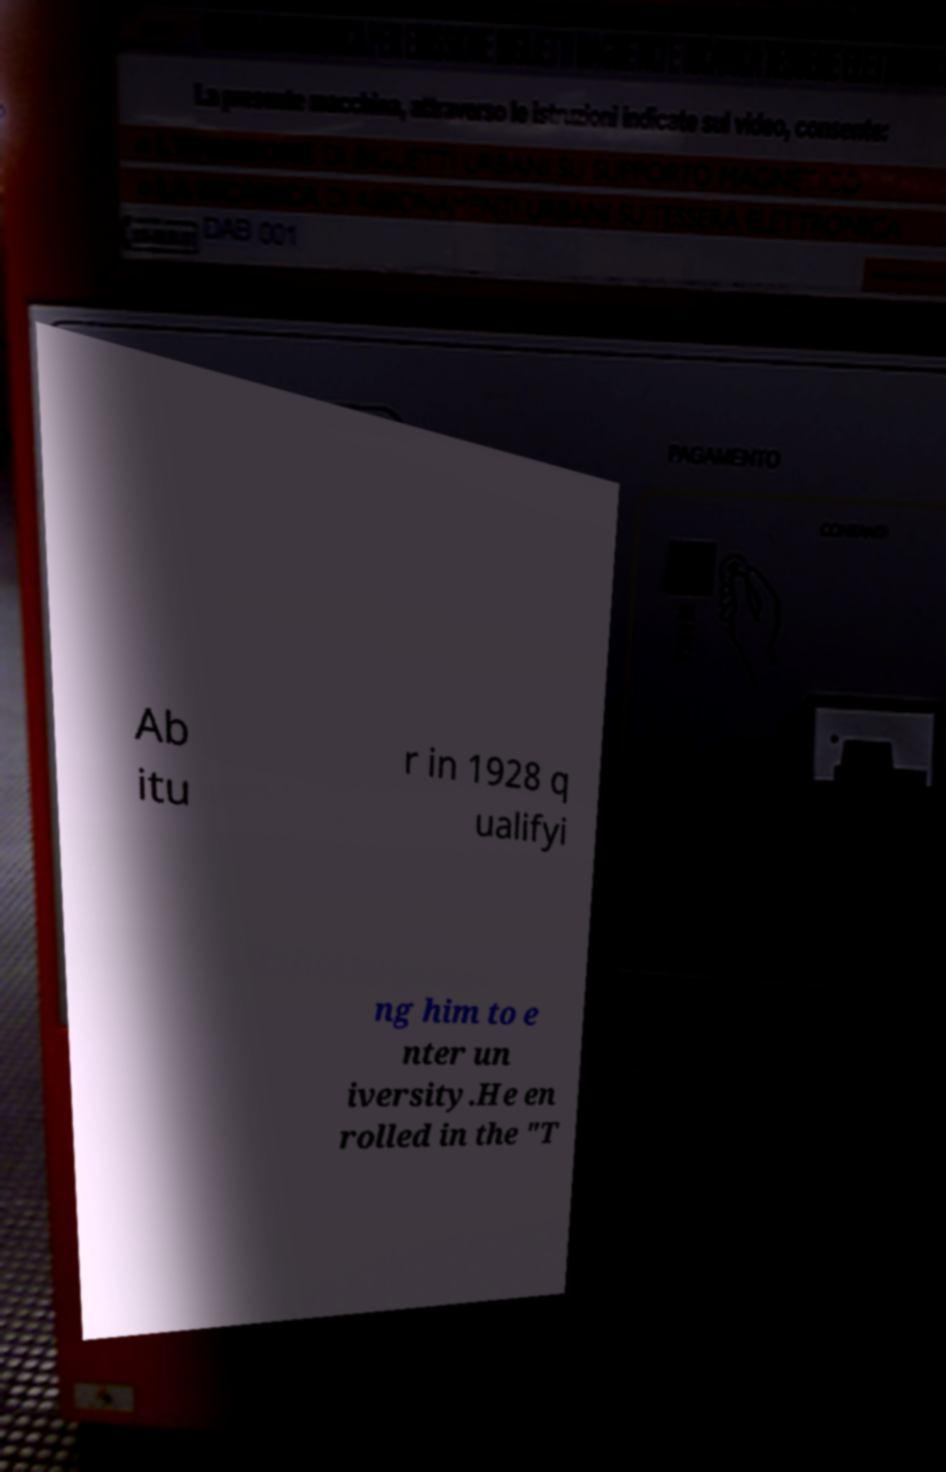Can you read and provide the text displayed in the image?This photo seems to have some interesting text. Can you extract and type it out for me? Ab itu r in 1928 q ualifyi ng him to e nter un iversity.He en rolled in the "T 